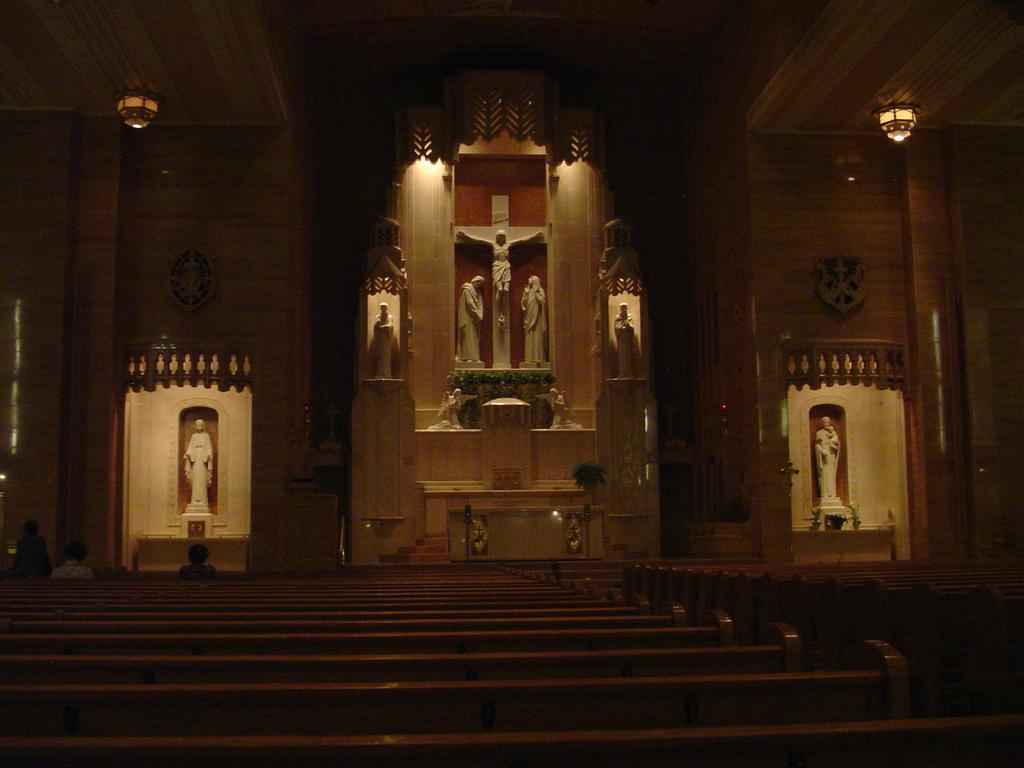What type of building is in the image? There is a church in the image. What can be found inside the church? The church contains sculptures. Where are the lights located in the image? There is a light in the top left and top right of the image. What might people use to sit in the church? There are benches at the bottom of the image. What type of animal can be seen answering questions in the image? There is no animal present in the image, let alone one answering questions. 